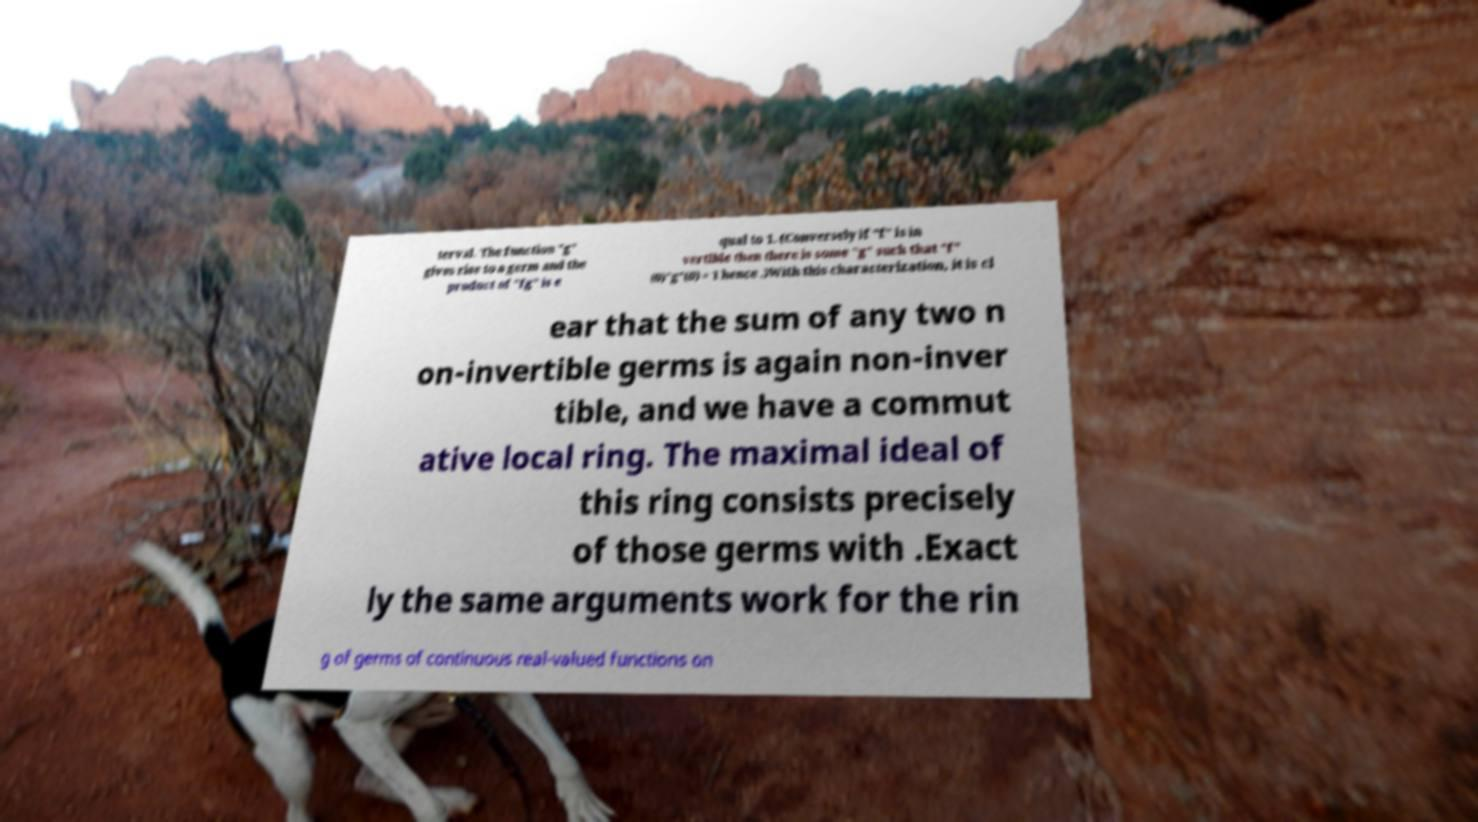What messages or text are displayed in this image? I need them in a readable, typed format. terval. The function "g" gives rise to a germ and the product of "fg" is e qual to 1. (Conversely if "f" is in vertible then there is some "g" such that "f" (0)"g"(0) = 1 hence .)With this characterization, it is cl ear that the sum of any two n on-invertible germs is again non-inver tible, and we have a commut ative local ring. The maximal ideal of this ring consists precisely of those germs with .Exact ly the same arguments work for the rin g of germs of continuous real-valued functions on 